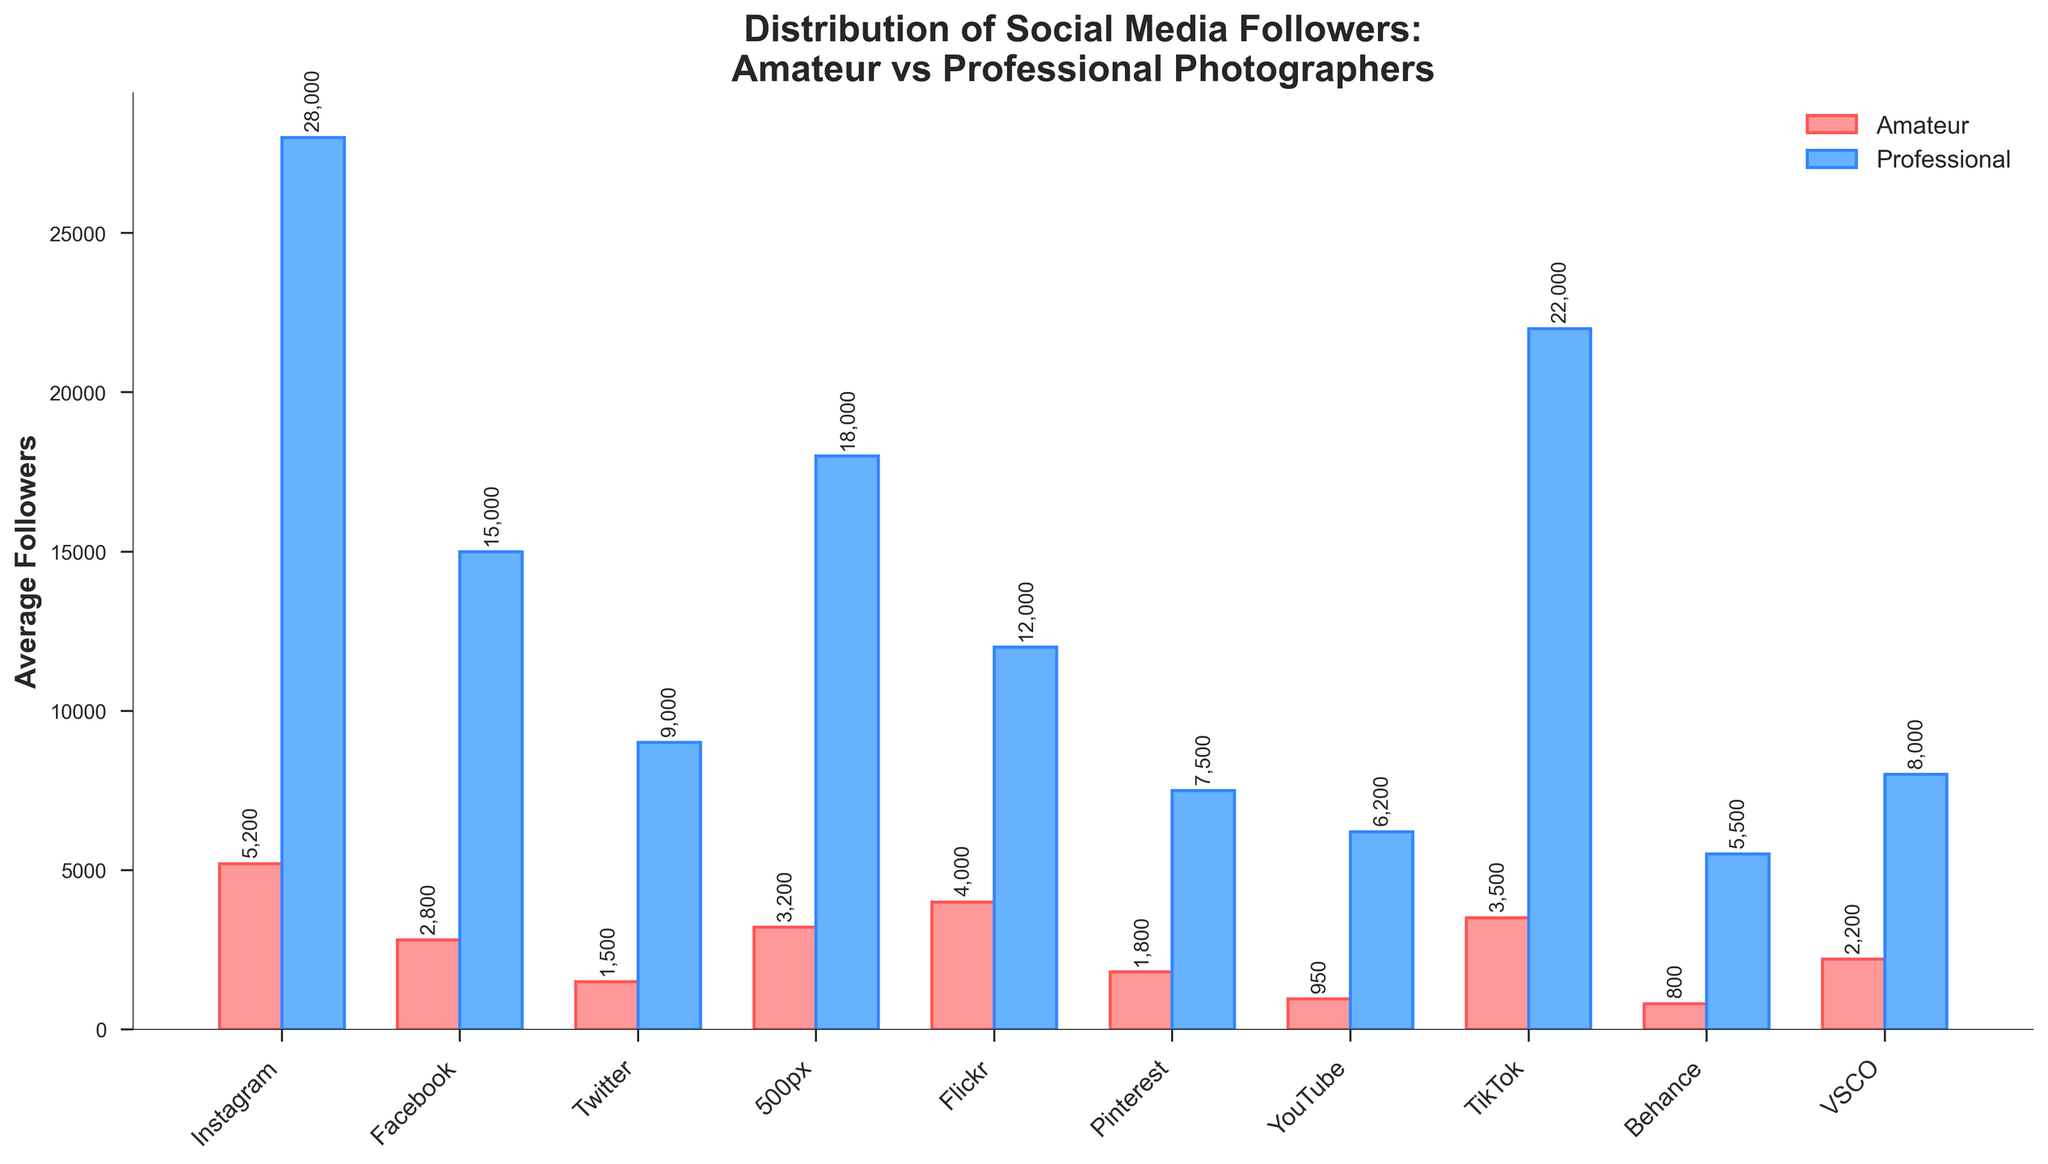Which platform has the highest average followers for professional photographers? By observing the bar chart, find the tallest blue bar representing the followers for professional photographers.
Answer: Instagram Which platform has the smallest difference in average followers between amateur and professional photographers? Calculate the absolute difference for each platform and find the smallest one: Instagram (22800), Facebook (12200), Twitter (7500), 500px (14800), Flickr (8000), Pinterest (5700), YouTube (5250), TikTok (18500), Behance (4700), VSCO (5800).
Answer: Behance How many platforms have professional photographers with more than 10,000 average followers? Count the number of blue bars that are taller than the 10,000 followers mark.
Answer: 6 Which platform sees the closest average number of followers between amateur and professional photographers? Compare the red and blue bars for each platform to find the closest visually.
Answer: Behance Across how many platforms do professional photographers have at least double the average followers compared to amateurs? Check visually where the blue bars are over twice the height of the red bars: Instagram, 500px, and TikTok.
Answer: 3 Which platform shows the smallest visual height difference between amateur and professional photographers' bars? Find the pair of bars (one red and one blue) that are nearly the same height.
Answer: Behance What is the total average number of followers for professional photographers across all platforms combined? Sum the average followers for professional photographers for all platforms: 28000 + 15000 + 9000 + 18000 + 12000 + 7500 + 6200 + 22000 + 5500 + 8000 = 131200.
Answer: 131200 On which platform do amateur photographers have higher average followers than professional photographers? Compare each pair of bars and find where the red bar is taller.
Answer: None Which three platforms have the highest number of average followers for amateur photographers? Identify the top three tallest red bars.
Answer: Instagram, Flickr, 500px What is the difference in average followers between amateur and professional photographers on TikTok? Subtract the average followers for amateurs from professionals on TikTok: 22000 - 3500 = 18500.
Answer: 18500 